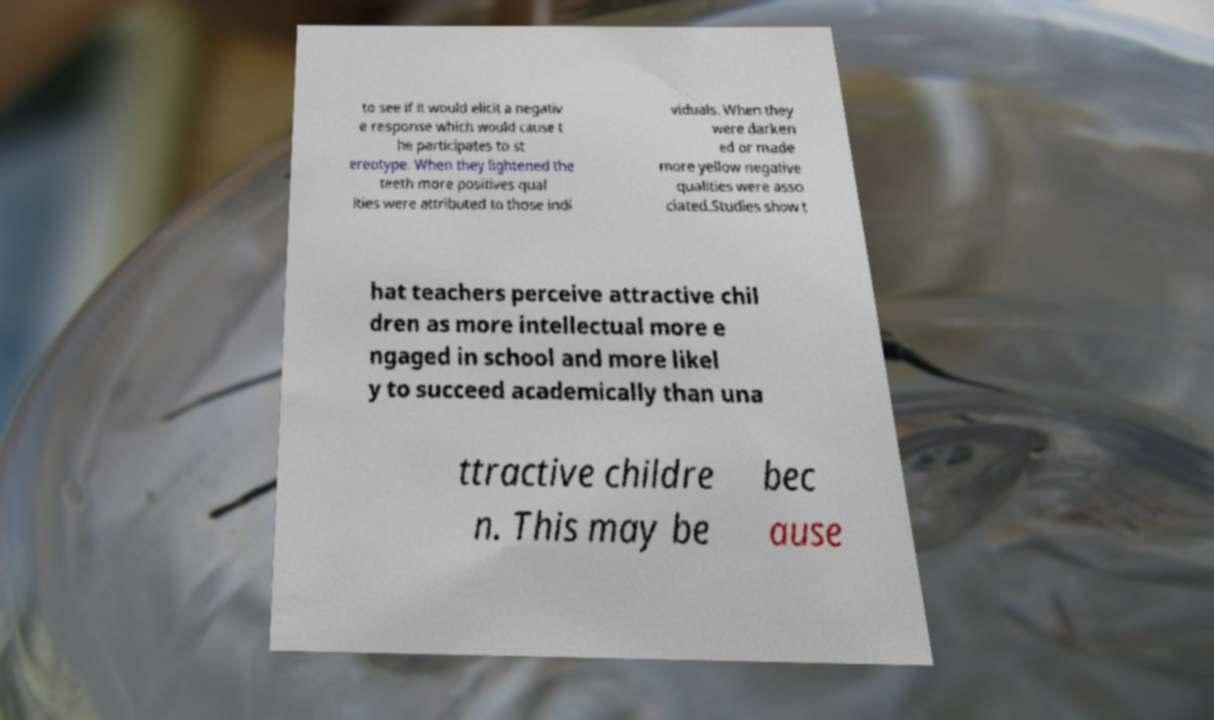Please identify and transcribe the text found in this image. to see if it would elicit a negativ e response which would cause t he participates to st ereotype. When they lightened the teeth more positives qual ities were attributed to those indi viduals. When they were darken ed or made more yellow negative qualities were asso ciated.Studies show t hat teachers perceive attractive chil dren as more intellectual more e ngaged in school and more likel y to succeed academically than una ttractive childre n. This may be bec ause 